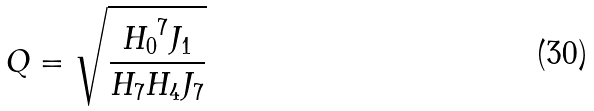<formula> <loc_0><loc_0><loc_500><loc_500>Q = \sqrt { \frac { { H _ { 0 } } ^ { 7 } J _ { 1 } } { H _ { 7 } H _ { 4 } J _ { 7 } } }</formula> 